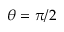<formula> <loc_0><loc_0><loc_500><loc_500>\theta = \pi / 2</formula> 